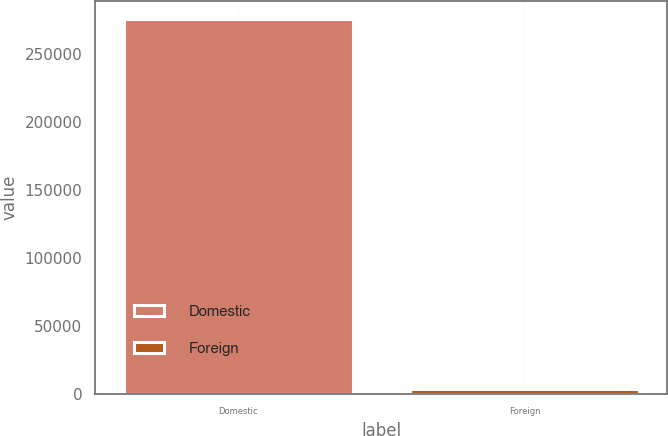<chart> <loc_0><loc_0><loc_500><loc_500><bar_chart><fcel>Domestic<fcel>Foreign<nl><fcel>275091<fcel>4050<nl></chart> 